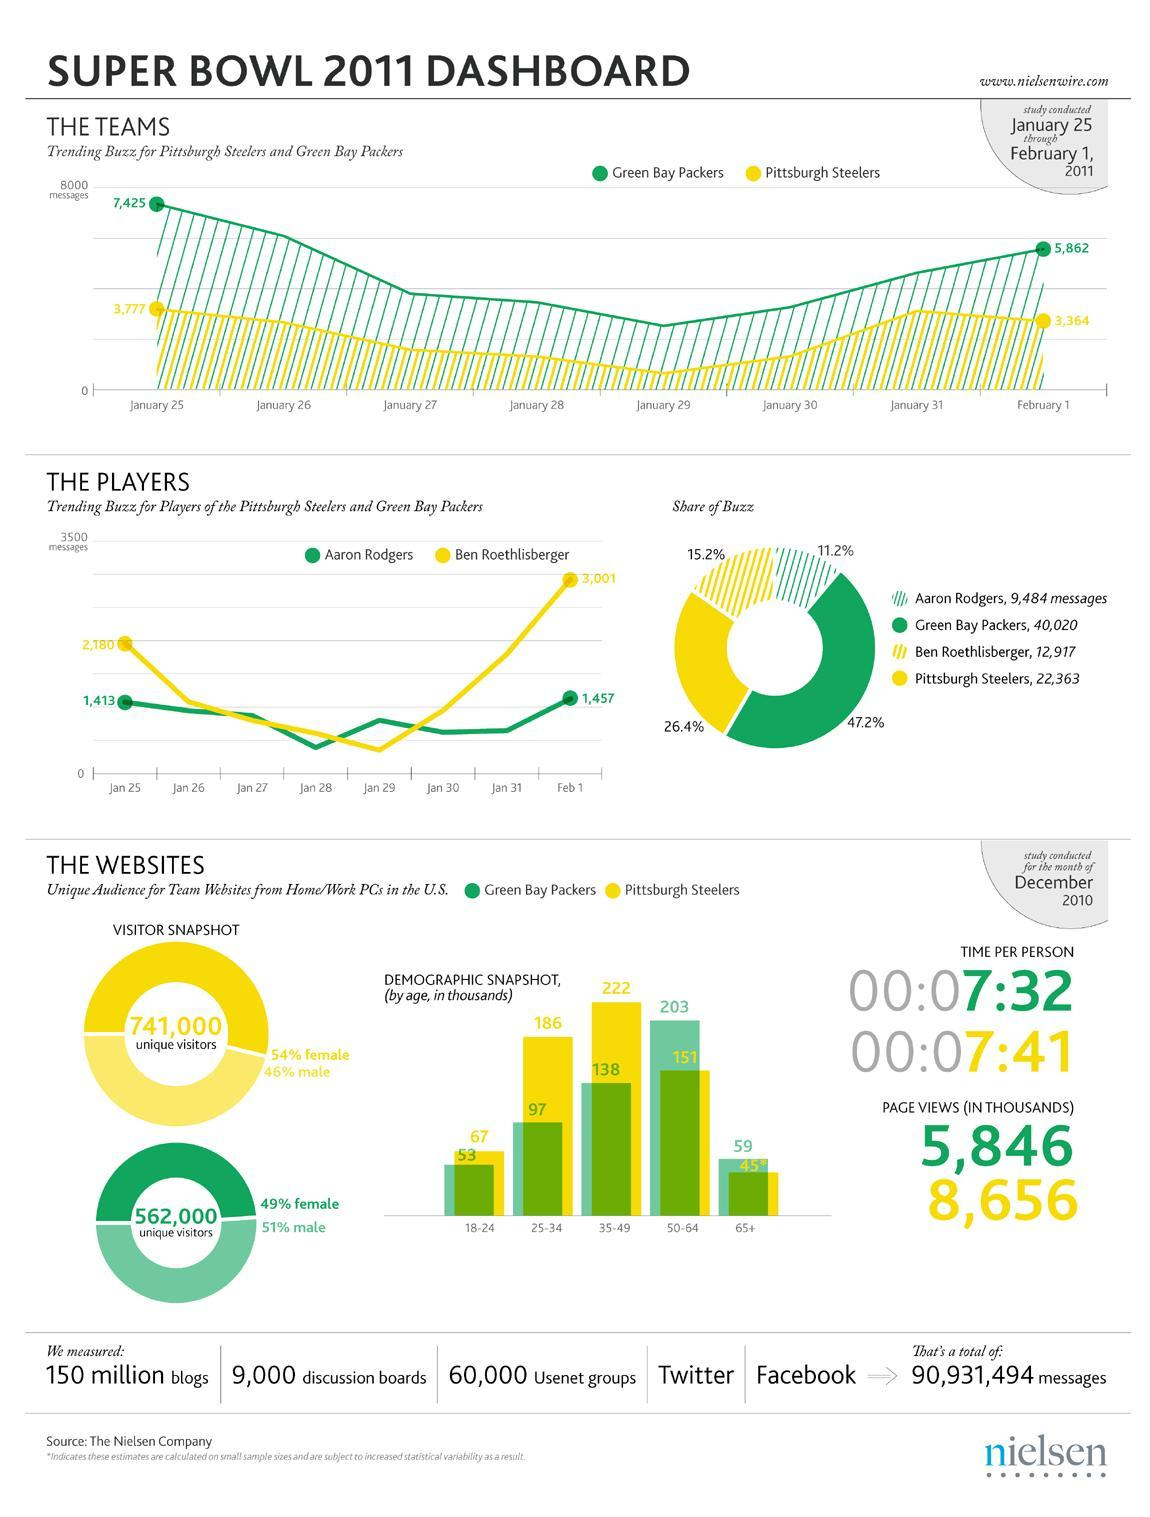How much is the media buzz of Ben?
Answer the question with a short phrase. 15.2% What is the media buzz of Aaron Rodgers and Green Bay Packers together? 58.4 Who is closer to reach 3500 messages? Ben How many messages came for Ben on Jan 25? 2,180 How many messages came for Aaron Rodgers on Feb 1? 1,457 How much is the media buzz of Green Bay Packers? 47.2% How much is the media buzz of Pittsburgh Steelers? 26.4% How many more messages did Ben receive on 1st February than 25th January? 821 How much is the media buzz of Aaron Rodgers? 11.2% What is the media buzz of Ben and Pittsburgh Steelers together? 41.6 